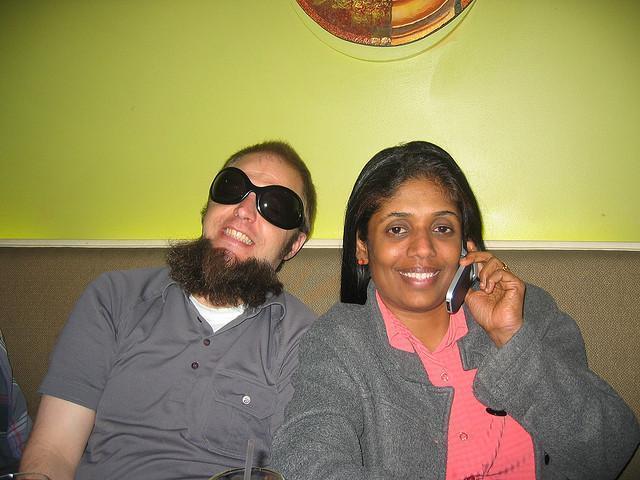How many people are there?
Give a very brief answer. 2. How many headlights does this truck have?
Give a very brief answer. 0. 